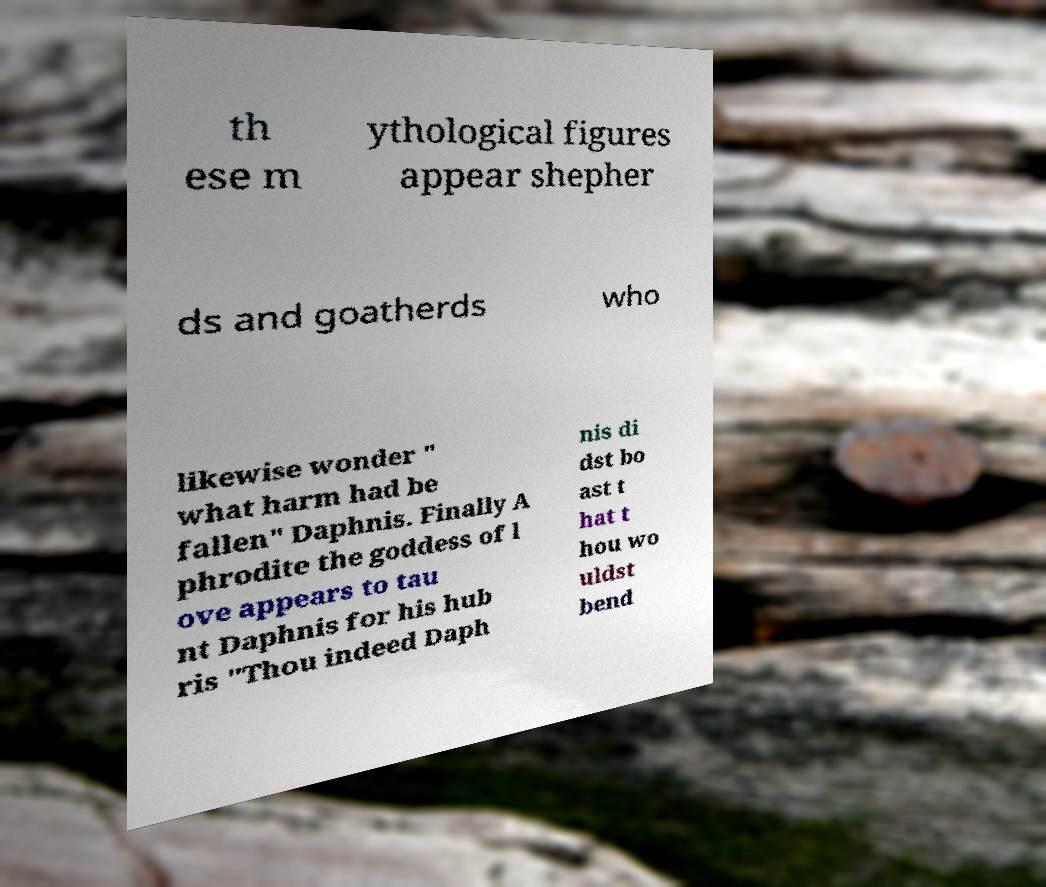Can you read and provide the text displayed in the image?This photo seems to have some interesting text. Can you extract and type it out for me? th ese m ythological figures appear shepher ds and goatherds who likewise wonder " what harm had be fallen" Daphnis. Finally A phrodite the goddess of l ove appears to tau nt Daphnis for his hub ris "Thou indeed Daph nis di dst bo ast t hat t hou wo uldst bend 